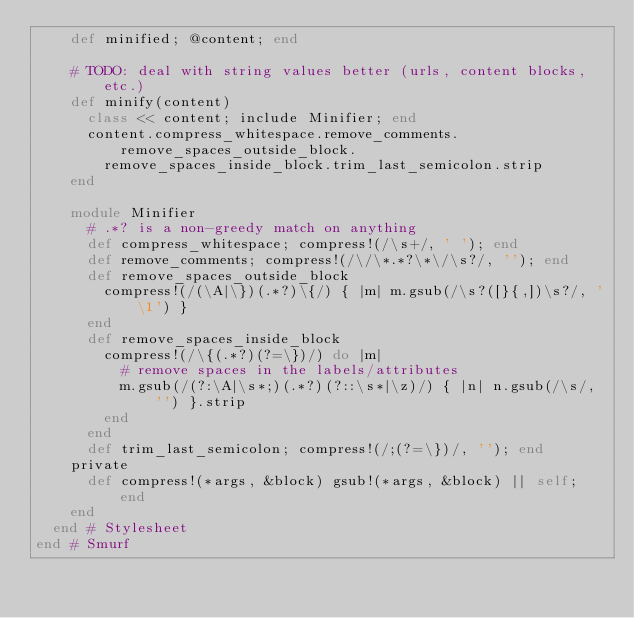Convert code to text. <code><loc_0><loc_0><loc_500><loc_500><_Ruby_>    def minified; @content; end

    # TODO: deal with string values better (urls, content blocks, etc.)
    def minify(content)
      class << content; include Minifier; end
      content.compress_whitespace.remove_comments.remove_spaces_outside_block.
        remove_spaces_inside_block.trim_last_semicolon.strip
    end

    module Minifier
      # .*? is a non-greedy match on anything
      def compress_whitespace; compress!(/\s+/, ' '); end
      def remove_comments; compress!(/\/\*.*?\*\/\s?/, ''); end
      def remove_spaces_outside_block
        compress!(/(\A|\})(.*?)\{/) { |m| m.gsub(/\s?([}{,])\s?/, '\1') }
      end
      def remove_spaces_inside_block
        compress!(/\{(.*?)(?=\})/) do |m|
          # remove spaces in the labels/attributes
          m.gsub(/(?:\A|\s*;)(.*?)(?::\s*|\z)/) { |n| n.gsub(/\s/, '') }.strip
        end
      end
      def trim_last_semicolon; compress!(/;(?=\})/, ''); end
    private
      def compress!(*args, &block) gsub!(*args, &block) || self; end
    end
  end # Stylesheet
end # Smurf
</code> 